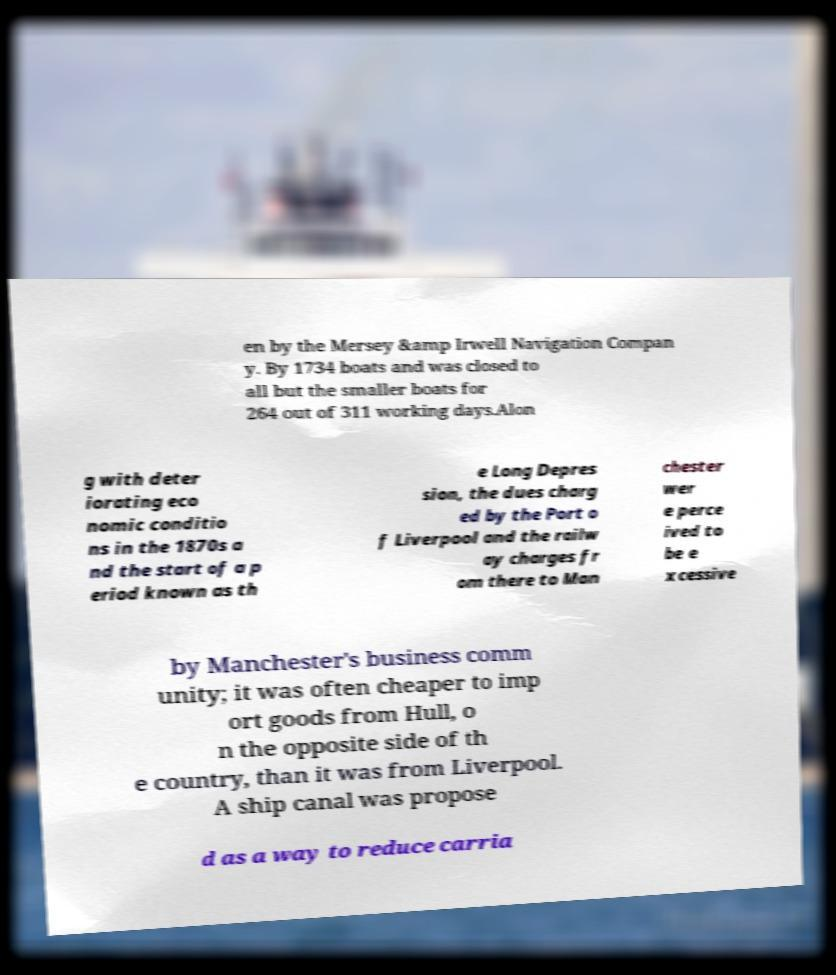I need the written content from this picture converted into text. Can you do that? en by the Mersey &amp Irwell Navigation Compan y. By 1734 boats and was closed to all but the smaller boats for 264 out of 311 working days.Alon g with deter iorating eco nomic conditio ns in the 1870s a nd the start of a p eriod known as th e Long Depres sion, the dues charg ed by the Port o f Liverpool and the railw ay charges fr om there to Man chester wer e perce ived to be e xcessive by Manchester's business comm unity; it was often cheaper to imp ort goods from Hull, o n the opposite side of th e country, than it was from Liverpool. A ship canal was propose d as a way to reduce carria 